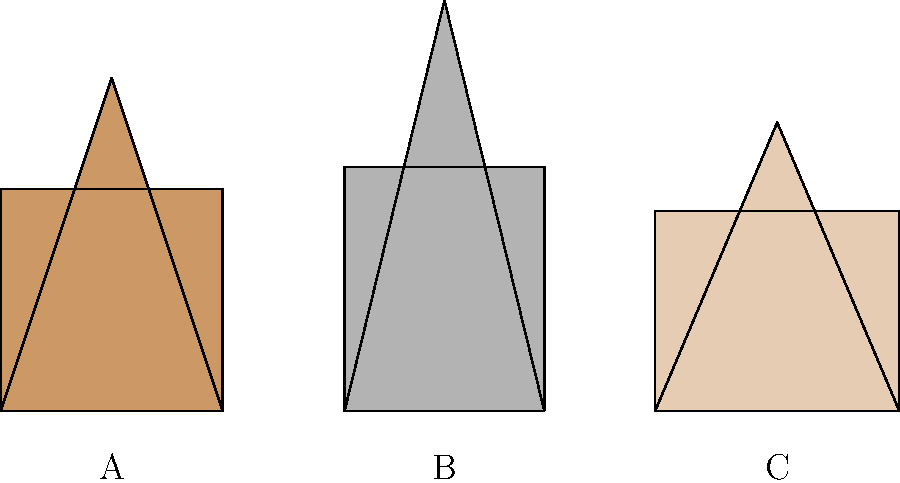As a tourism promoter passionate about Croatian architecture, identify which of the depicted house styles (A, B, or C) is most representative of traditional Dalmatian architecture? To answer this question, let's analyze the characteristics of each house style and compare them to traditional Dalmatian architecture:

1. House A:
   - Wide and low profile
   - Gently sloping roof
   - Warm, earthy color (light brown or beige)
   These features are typical of Dalmatian architecture, which is adapted to the Mediterranean climate.

2. House B:
   - Taller and narrower profile
   - Steep, pointed roof
   - Gray coloration
   These characteristics are more reminiscent of Istrian architecture, influenced by Central European styles.

3. House C:
   - Wider than it is tall
   - Low-pitched roof
   - Light, warm coloration
   These features are common in Slavonian architecture, typical of the eastern continental region of Croatia.

Dalmatian architecture is characterized by its adaptation to the Mediterranean climate, with features that provide shade and ventilation. The wide, low profile and gently sloping roof of House A are perfect examples of this style. The warm, earthy color is also typical of the stone used in Dalmatian construction.

Therefore, House A is the most representative of traditional Dalmatian architecture among the given options.
Answer: A 